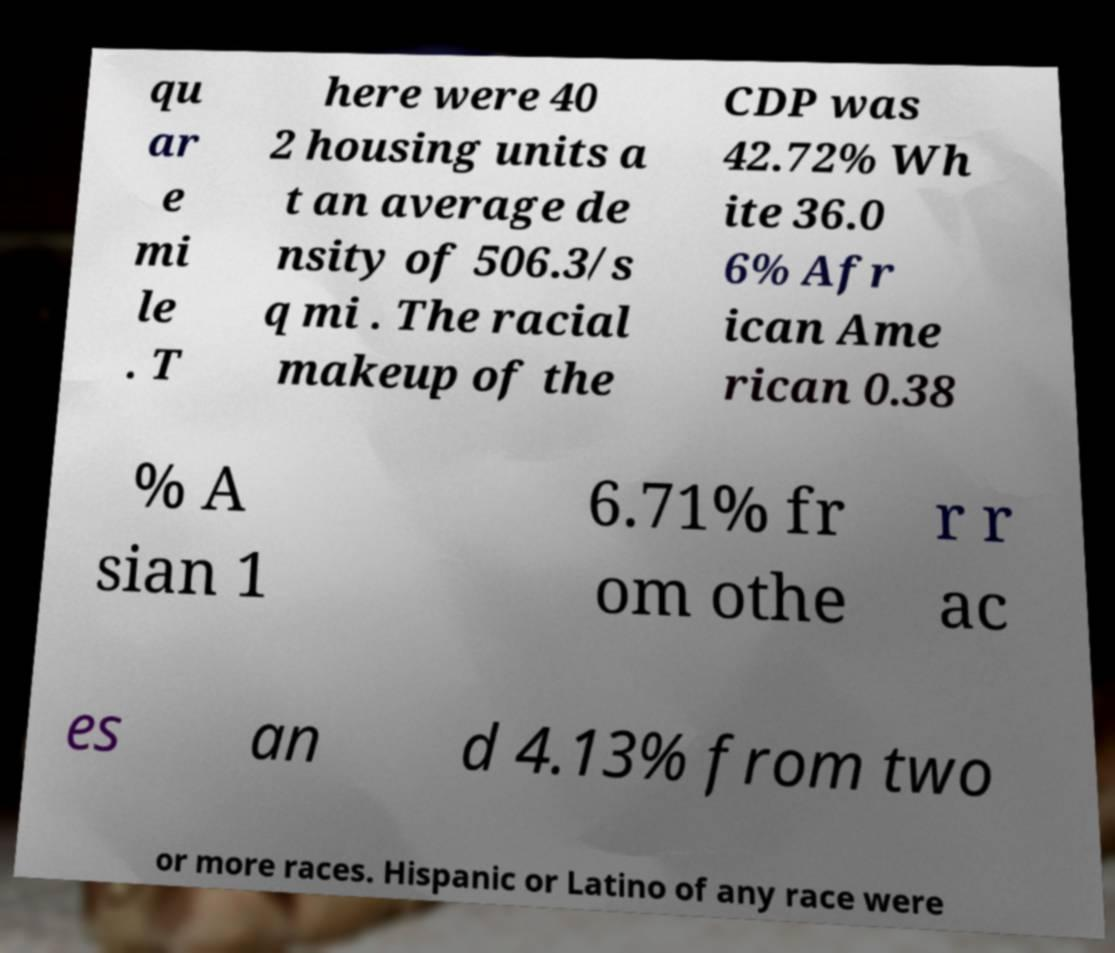Please identify and transcribe the text found in this image. qu ar e mi le . T here were 40 2 housing units a t an average de nsity of 506.3/s q mi . The racial makeup of the CDP was 42.72% Wh ite 36.0 6% Afr ican Ame rican 0.38 % A sian 1 6.71% fr om othe r r ac es an d 4.13% from two or more races. Hispanic or Latino of any race were 